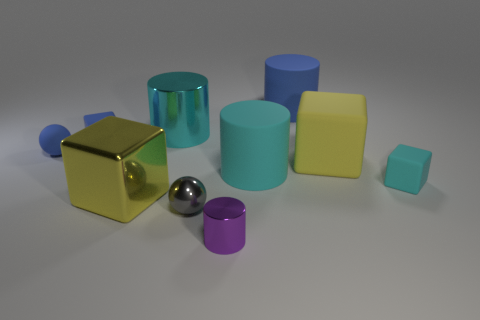What number of things are either blocks that are to the right of the large cyan rubber cylinder or yellow metallic things to the left of the cyan metal cylinder?
Your response must be concise. 3. There is a cube that is the same size as the yellow shiny thing; what is it made of?
Your response must be concise. Rubber. What color is the tiny rubber ball?
Give a very brief answer. Blue. What is the material of the blue thing that is behind the tiny blue sphere and to the left of the purple shiny cylinder?
Provide a succinct answer. Rubber. Is there a matte thing that is behind the yellow object that is behind the small cube in front of the tiny rubber ball?
Ensure brevity in your answer.  Yes. What size is the cylinder that is the same color as the rubber sphere?
Offer a terse response. Large. Are there any blocks to the right of the small gray sphere?
Your response must be concise. Yes. How many other objects are the same shape as the yellow metal object?
Keep it short and to the point. 3. There is a metallic cylinder that is the same size as the blue cube; what color is it?
Your answer should be very brief. Purple. Are there fewer small blue rubber balls to the left of the blue rubber sphere than small gray shiny objects left of the small cylinder?
Ensure brevity in your answer.  Yes. 